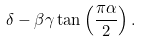Convert formula to latex. <formula><loc_0><loc_0><loc_500><loc_500>\delta - \beta \gamma \tan \left ( { \frac { \pi \alpha } { 2 } } \right ) .</formula> 